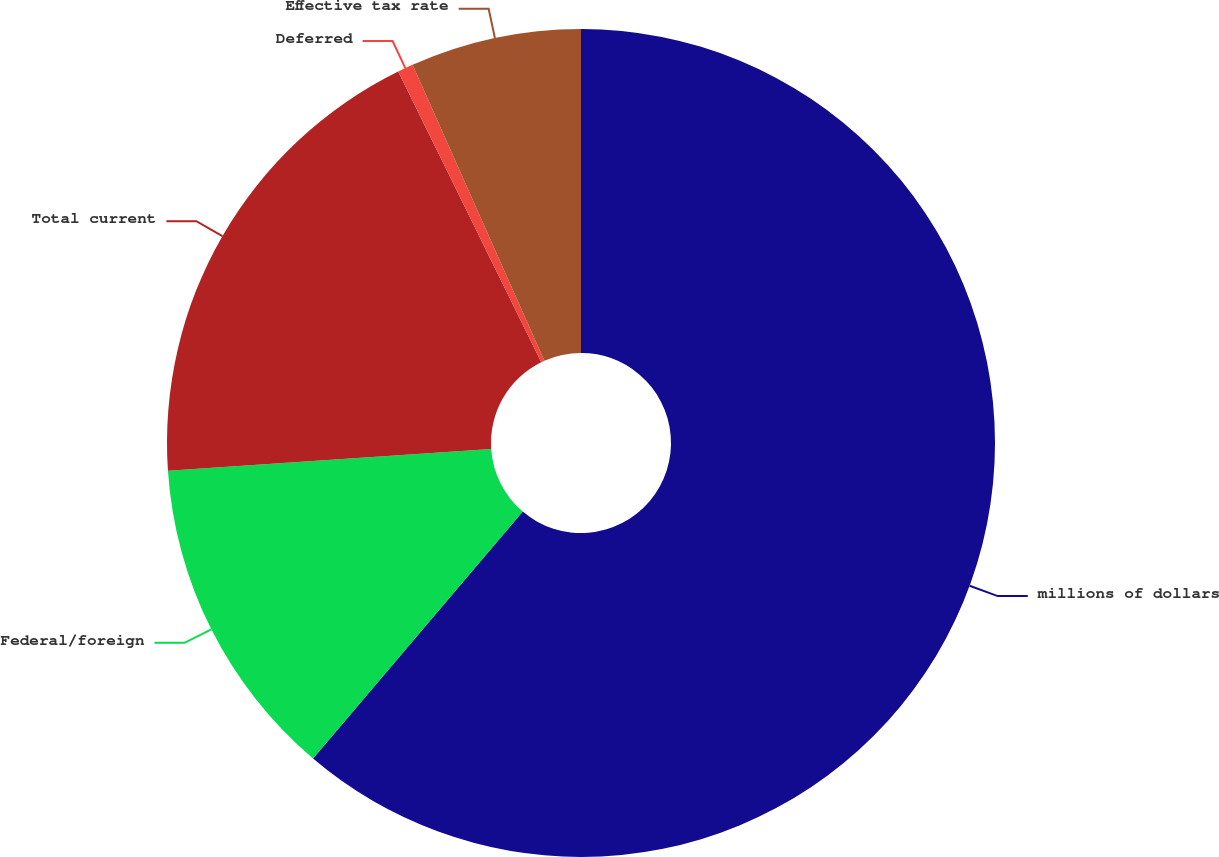Convert chart. <chart><loc_0><loc_0><loc_500><loc_500><pie_chart><fcel>millions of dollars<fcel>Federal/foreign<fcel>Total current<fcel>Deferred<fcel>Effective tax rate<nl><fcel>61.21%<fcel>12.73%<fcel>18.79%<fcel>0.61%<fcel>6.67%<nl></chart> 